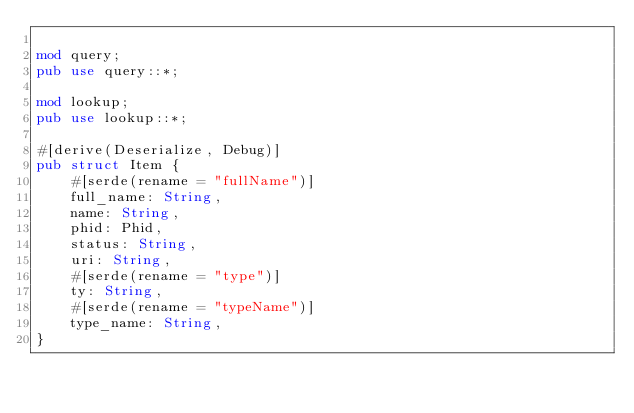Convert code to text. <code><loc_0><loc_0><loc_500><loc_500><_Rust_>
mod query;
pub use query::*;

mod lookup;
pub use lookup::*;

#[derive(Deserialize, Debug)]
pub struct Item {
    #[serde(rename = "fullName")]
    full_name: String,
    name: String,
    phid: Phid,
    status: String,
    uri: String,
    #[serde(rename = "type")]
    ty: String,
    #[serde(rename = "typeName")]
    type_name: String,
}
</code> 